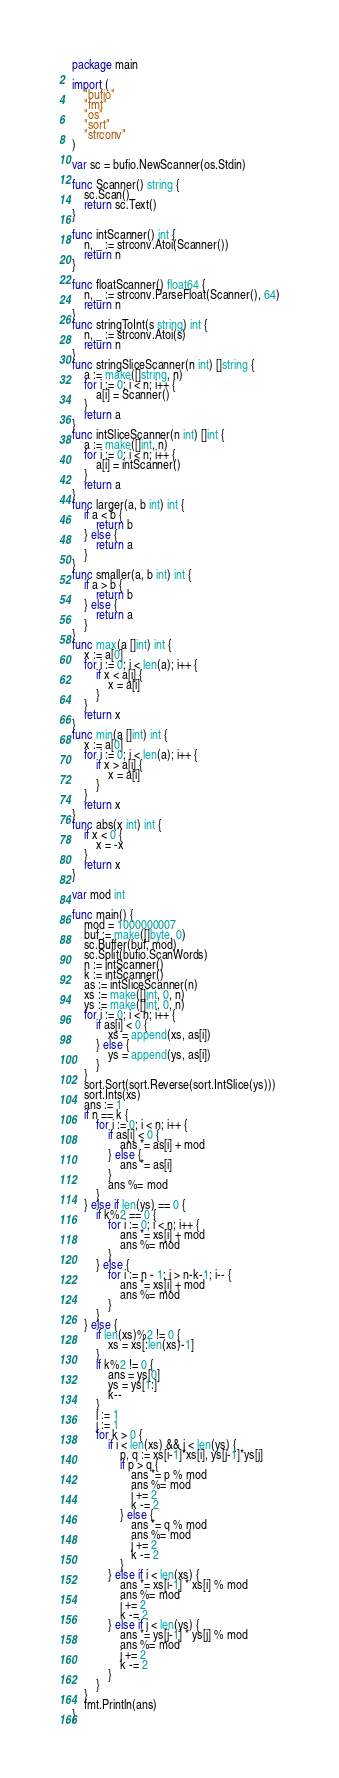Convert code to text. <code><loc_0><loc_0><loc_500><loc_500><_Go_>package main

import (
	"bufio"
	"fmt"
	"os"
	"sort"
	"strconv"
)

var sc = bufio.NewScanner(os.Stdin)

func Scanner() string {
	sc.Scan()
	return sc.Text()
}

func intScanner() int {
	n, _ := strconv.Atoi(Scanner())
	return n
}

func floatScanner() float64 {
	n, _ := strconv.ParseFloat(Scanner(), 64)
	return n
}
func stringToInt(s string) int {
	n, _ := strconv.Atoi(s)
	return n
}
func stringSliceScanner(n int) []string {
	a := make([]string, n)
	for i := 0; i < n; i++ {
		a[i] = Scanner()
	}
	return a
}
func intSliceScanner(n int) []int {
	a := make([]int, n)
	for i := 0; i < n; i++ {
		a[i] = intScanner()
	}
	return a
}
func larger(a, b int) int {
	if a < b {
		return b
	} else {
		return a
	}
}
func smaller(a, b int) int {
	if a > b {
		return b
	} else {
		return a
	}
}
func max(a []int) int {
	x := a[0]
	for i := 0; i < len(a); i++ {
		if x < a[i] {
			x = a[i]
		}
	}
	return x
}
func min(a []int) int {
	x := a[0]
	for i := 0; i < len(a); i++ {
		if x > a[i] {
			x = a[i]
		}
	}
	return x
}
func abs(x int) int {
	if x < 0 {
		x = -x
	}
	return x
}

var mod int

func main() {
	mod = 1000000007
	buf := make([]byte, 0)
	sc.Buffer(buf, mod)
	sc.Split(bufio.ScanWords)
	n := intScanner()
	k := intScanner()
	as := intSliceScanner(n)
	xs := make([]int, 0, n)
	ys := make([]int, 0, n)
	for i := 0; i < n; i++ {
		if as[i] < 0 {
			xs = append(xs, as[i])
		} else {
			ys = append(ys, as[i])
		}
	}
	sort.Sort(sort.Reverse(sort.IntSlice(ys)))
	sort.Ints(xs)
	ans := 1
	if n == k {
		for i := 0; i < n; i++ {
			if as[i] < 0 {
				ans *= as[i] + mod
			} else {
				ans *= as[i]
			}
			ans %= mod
		}
	} else if len(ys) == 0 {
		if k%2 == 0 {
			for i := 0; i < n; i++ {
				ans *= xs[i] + mod
				ans %= mod
			}
		} else {
			for i := n - 1; i > n-k-1; i-- {
				ans *= xs[i] + mod
				ans %= mod
			}
		}
	} else {
		if len(xs)%2 != 0 {
			xs = xs[:len(xs)-1]
		}
		if k%2 != 0 {
			ans = ys[0]
			ys = ys[1:]
			k--
		}
		i := 1
		j := 1
		for k > 0 {
			if i < len(xs) && j < len(ys) {
				p, q := xs[i-1]*xs[i], ys[j-1]*ys[j]
				if p > q {
					ans *= p % mod
					ans %= mod
					i += 2
					k -= 2
				} else {
					ans *= q % mod
					ans %= mod
					j += 2
					k -= 2
				}
			} else if i < len(xs) {
				ans *= xs[i-1] * xs[i] % mod
				ans %= mod
				i += 2
				k -= 2
			} else if j < len(ys) {
				ans *= ys[j-1] * ys[j] % mod
				ans %= mod
				j += 2
				k -= 2
			}
		}
	}
	fmt.Println(ans)
}
</code> 